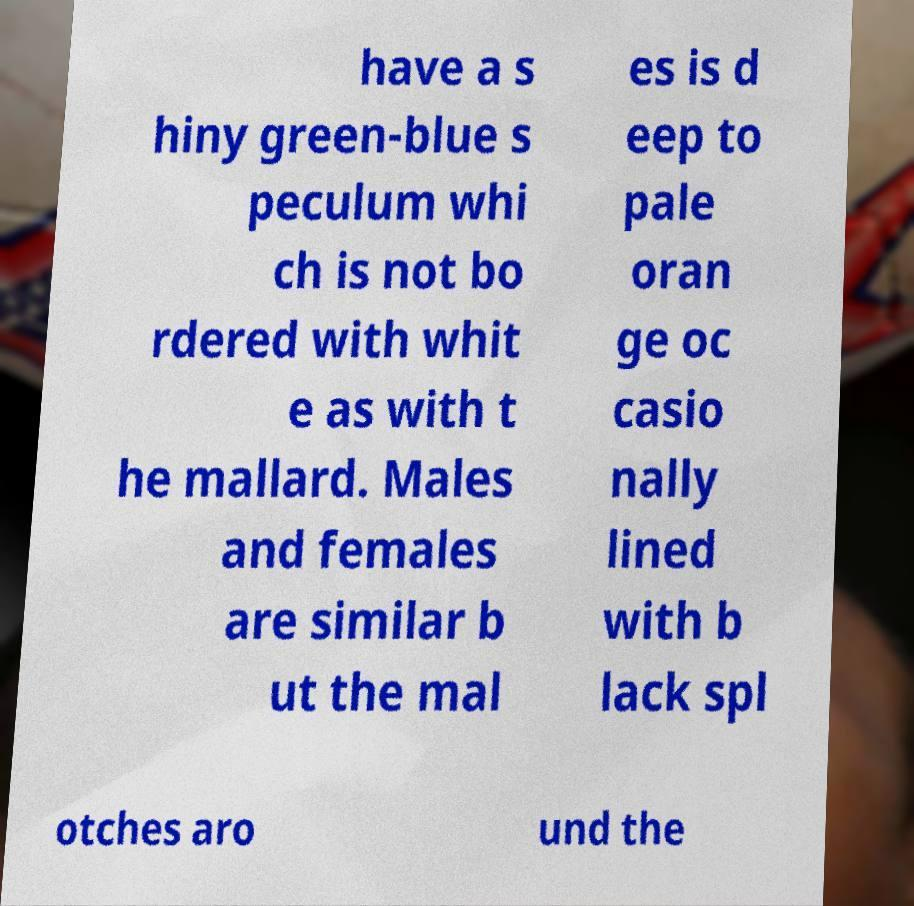Could you extract and type out the text from this image? have a s hiny green-blue s peculum whi ch is not bo rdered with whit e as with t he mallard. Males and females are similar b ut the mal es is d eep to pale oran ge oc casio nally lined with b lack spl otches aro und the 